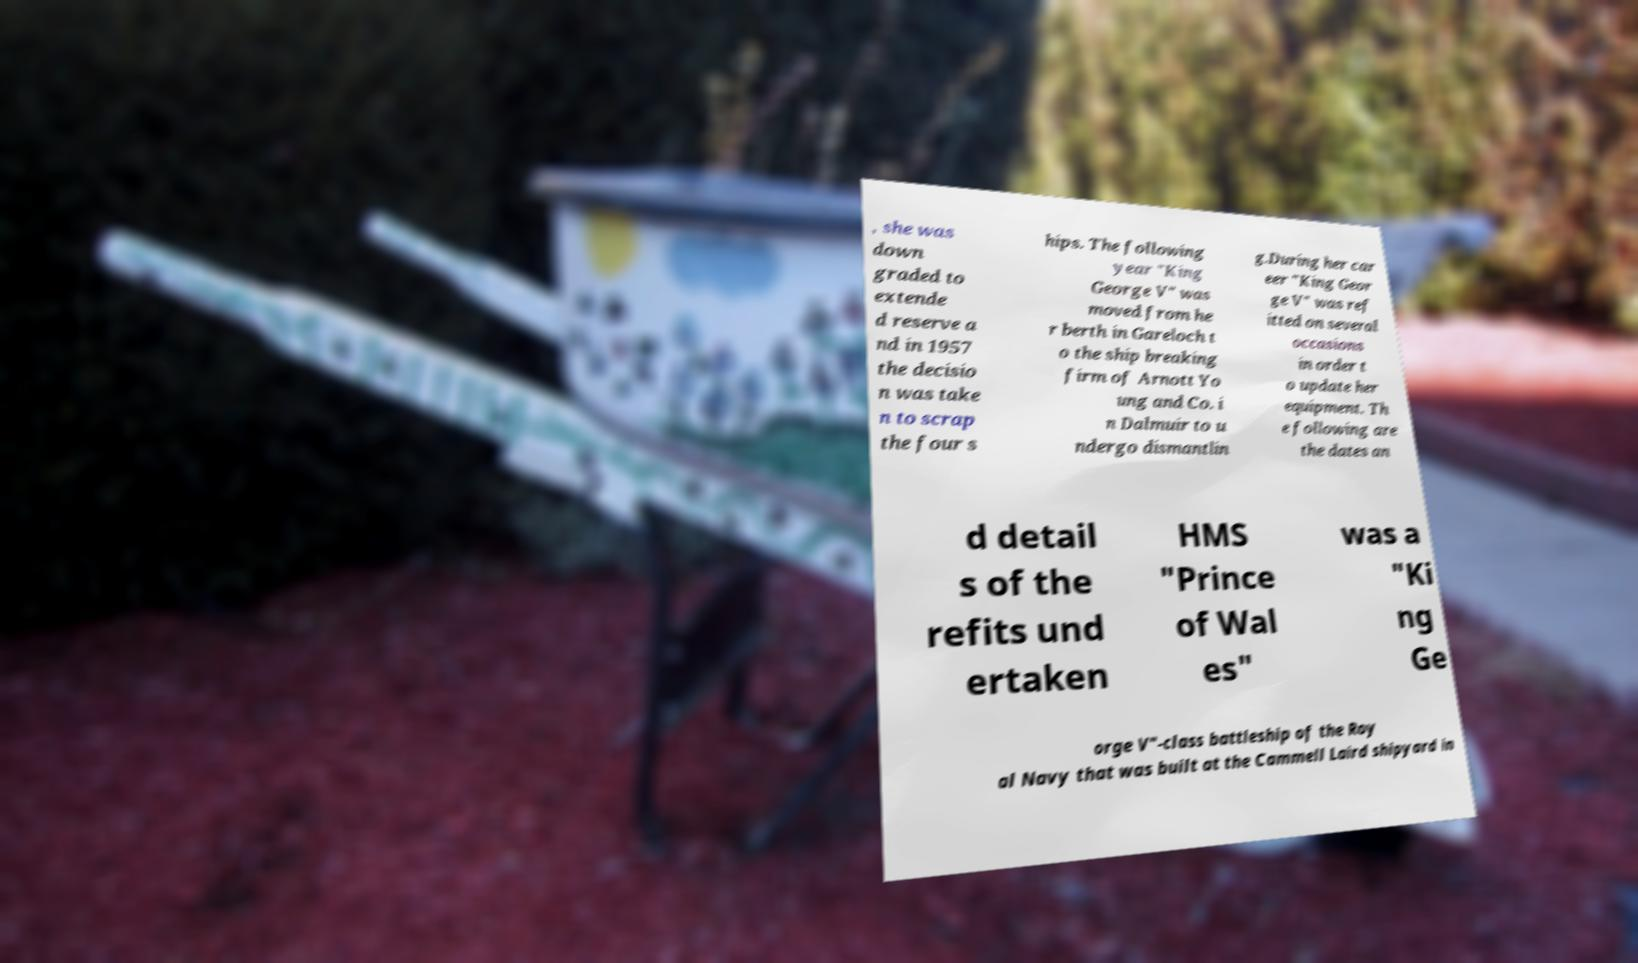Can you read and provide the text displayed in the image?This photo seems to have some interesting text. Can you extract and type it out for me? , she was down graded to extende d reserve a nd in 1957 the decisio n was take n to scrap the four s hips. The following year "King George V" was moved from he r berth in Gareloch t o the ship breaking firm of Arnott Yo ung and Co. i n Dalmuir to u ndergo dismantlin g.During her car eer "King Geor ge V" was ref itted on several occasions in order t o update her equipment. Th e following are the dates an d detail s of the refits und ertaken HMS "Prince of Wal es" was a "Ki ng Ge orge V"-class battleship of the Roy al Navy that was built at the Cammell Laird shipyard in 